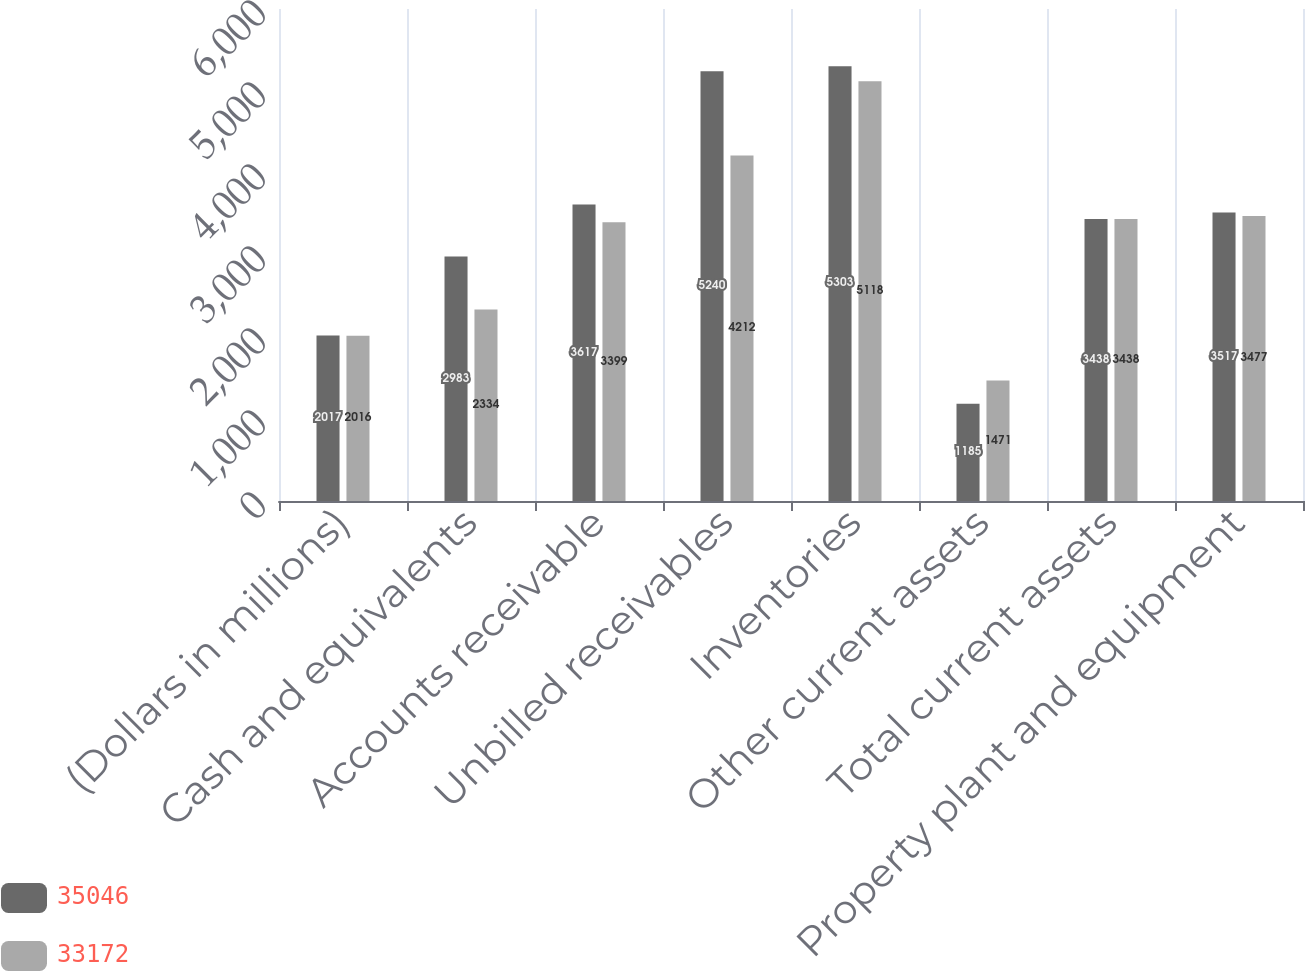<chart> <loc_0><loc_0><loc_500><loc_500><stacked_bar_chart><ecel><fcel>(Dollars in millions)<fcel>Cash and equivalents<fcel>Accounts receivable<fcel>Unbilled receivables<fcel>Inventories<fcel>Other current assets<fcel>Total current assets<fcel>Property plant and equipment<nl><fcel>35046<fcel>2017<fcel>2983<fcel>3617<fcel>5240<fcel>5303<fcel>1185<fcel>3438<fcel>3517<nl><fcel>33172<fcel>2016<fcel>2334<fcel>3399<fcel>4212<fcel>5118<fcel>1471<fcel>3438<fcel>3477<nl></chart> 